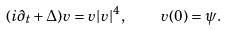<formula> <loc_0><loc_0><loc_500><loc_500>( i \partial _ { t } + \Delta ) v = v | v | ^ { 4 } , \quad v ( 0 ) = \psi .</formula> 